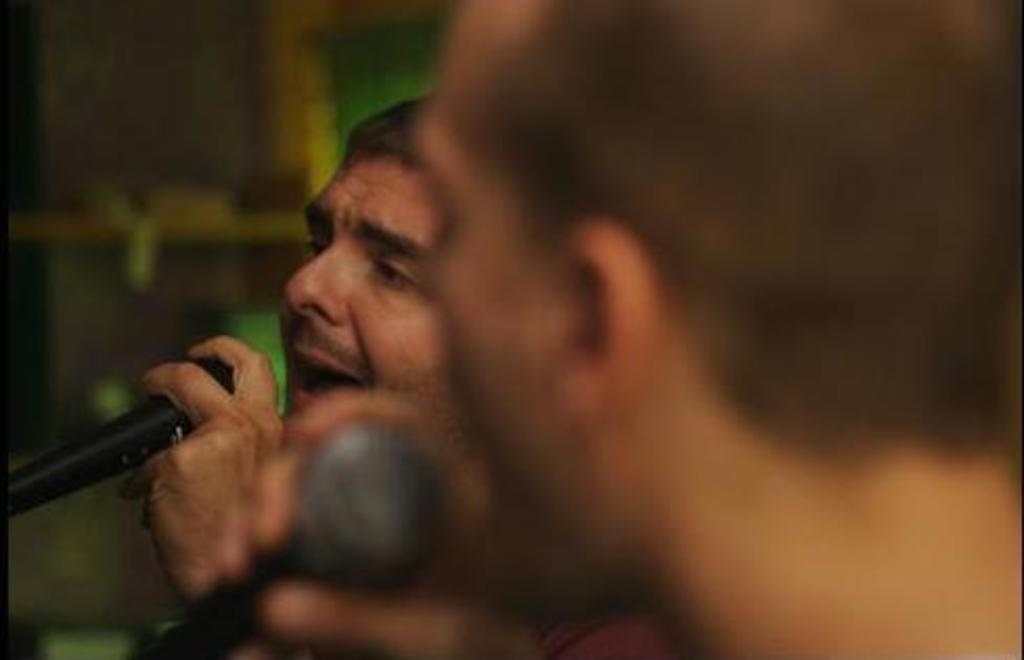How many people are in the image? There are two men in the image. What are the two men doing in the image? The two men are singing on a mic. What type of brake can be seen on the fifth man in the image? There are only two men in the image, and neither of them is wearing a brake or identified as the fifth man. 